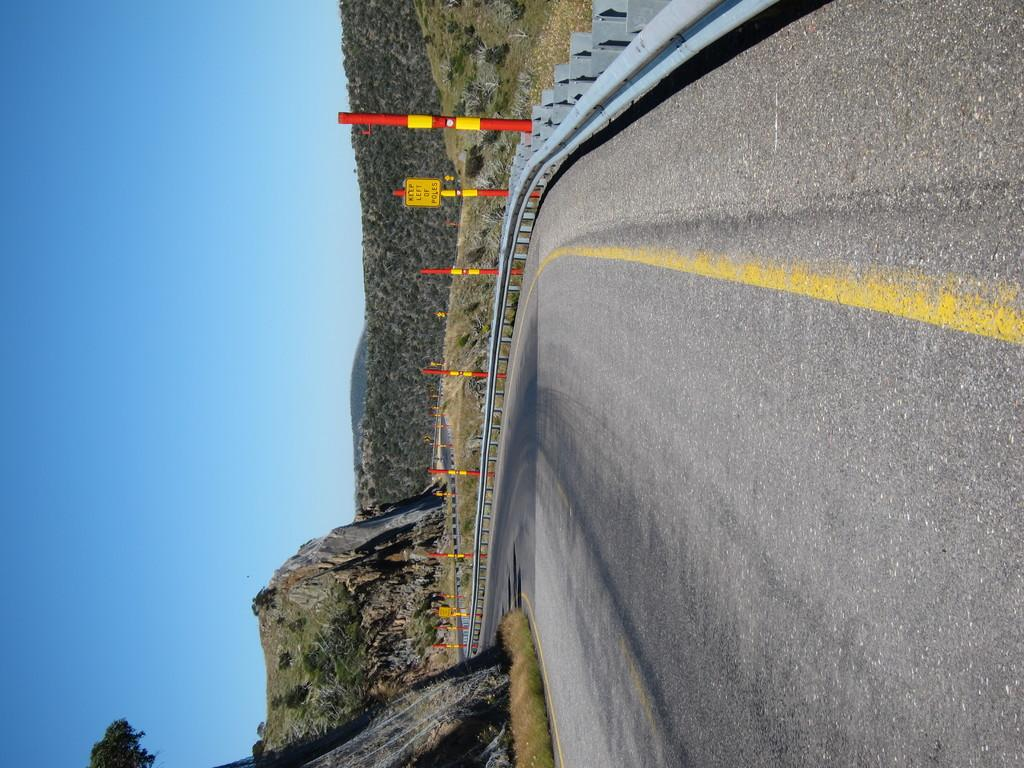How is the image oriented? The image is tilted. What is the main subject of the image? The image depicts a highway. Are there any vehicles or people on the highway? No, the road is empty. What natural features can be seen beside the highway? There are huge hills and mountains beside the road. What type of poles are present beside the road? There are red and yellow poles beside the road. Can you see a plantation of crops beside the road in the image? No, there is no plantation of crops visible in the image. What type of can is being used to observe the highway in the image? There is no can present in the image, and no one is using a can to observe the highway. 